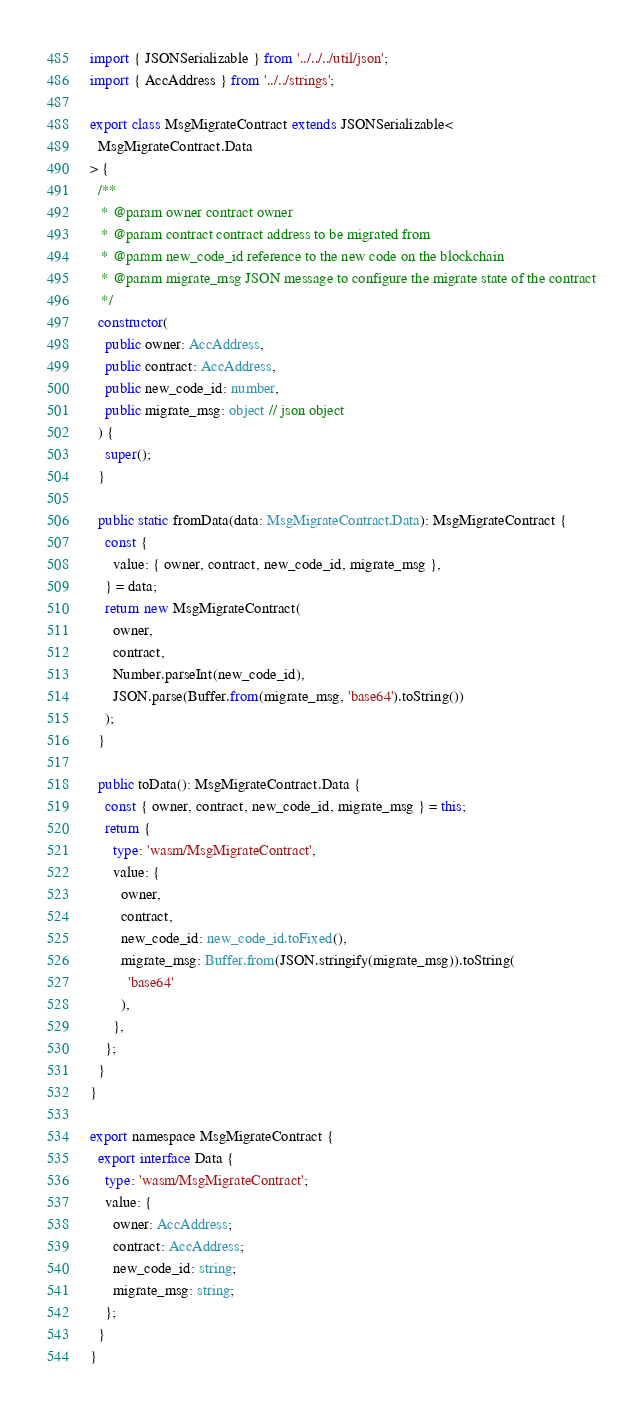<code> <loc_0><loc_0><loc_500><loc_500><_TypeScript_>import { JSONSerializable } from '../../../util/json';
import { AccAddress } from '../../strings';

export class MsgMigrateContract extends JSONSerializable<
  MsgMigrateContract.Data
> {
  /**
   * @param owner contract owner
   * @param contract contract address to be migrated from
   * @param new_code_id reference to the new code on the blockchain
   * @param migrate_msg JSON message to configure the migrate state of the contract
   */
  constructor(
    public owner: AccAddress,
    public contract: AccAddress,
    public new_code_id: number,
    public migrate_msg: object // json object
  ) {
    super();
  }

  public static fromData(data: MsgMigrateContract.Data): MsgMigrateContract {
    const {
      value: { owner, contract, new_code_id, migrate_msg },
    } = data;
    return new MsgMigrateContract(
      owner,
      contract,
      Number.parseInt(new_code_id),
      JSON.parse(Buffer.from(migrate_msg, 'base64').toString())
    );
  }

  public toData(): MsgMigrateContract.Data {
    const { owner, contract, new_code_id, migrate_msg } = this;
    return {
      type: 'wasm/MsgMigrateContract',
      value: {
        owner,
        contract,
        new_code_id: new_code_id.toFixed(),
        migrate_msg: Buffer.from(JSON.stringify(migrate_msg)).toString(
          'base64'
        ),
      },
    };
  }
}

export namespace MsgMigrateContract {
  export interface Data {
    type: 'wasm/MsgMigrateContract';
    value: {
      owner: AccAddress;
      contract: AccAddress;
      new_code_id: string;
      migrate_msg: string;
    };
  }
}
</code> 